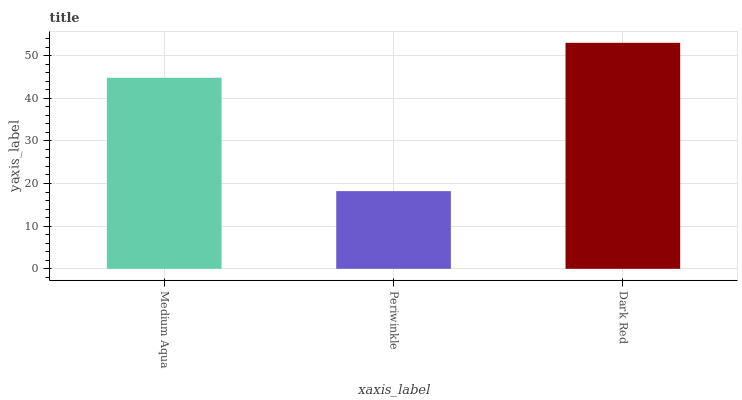Is Periwinkle the minimum?
Answer yes or no. Yes. Is Dark Red the maximum?
Answer yes or no. Yes. Is Dark Red the minimum?
Answer yes or no. No. Is Periwinkle the maximum?
Answer yes or no. No. Is Dark Red greater than Periwinkle?
Answer yes or no. Yes. Is Periwinkle less than Dark Red?
Answer yes or no. Yes. Is Periwinkle greater than Dark Red?
Answer yes or no. No. Is Dark Red less than Periwinkle?
Answer yes or no. No. Is Medium Aqua the high median?
Answer yes or no. Yes. Is Medium Aqua the low median?
Answer yes or no. Yes. Is Periwinkle the high median?
Answer yes or no. No. Is Periwinkle the low median?
Answer yes or no. No. 